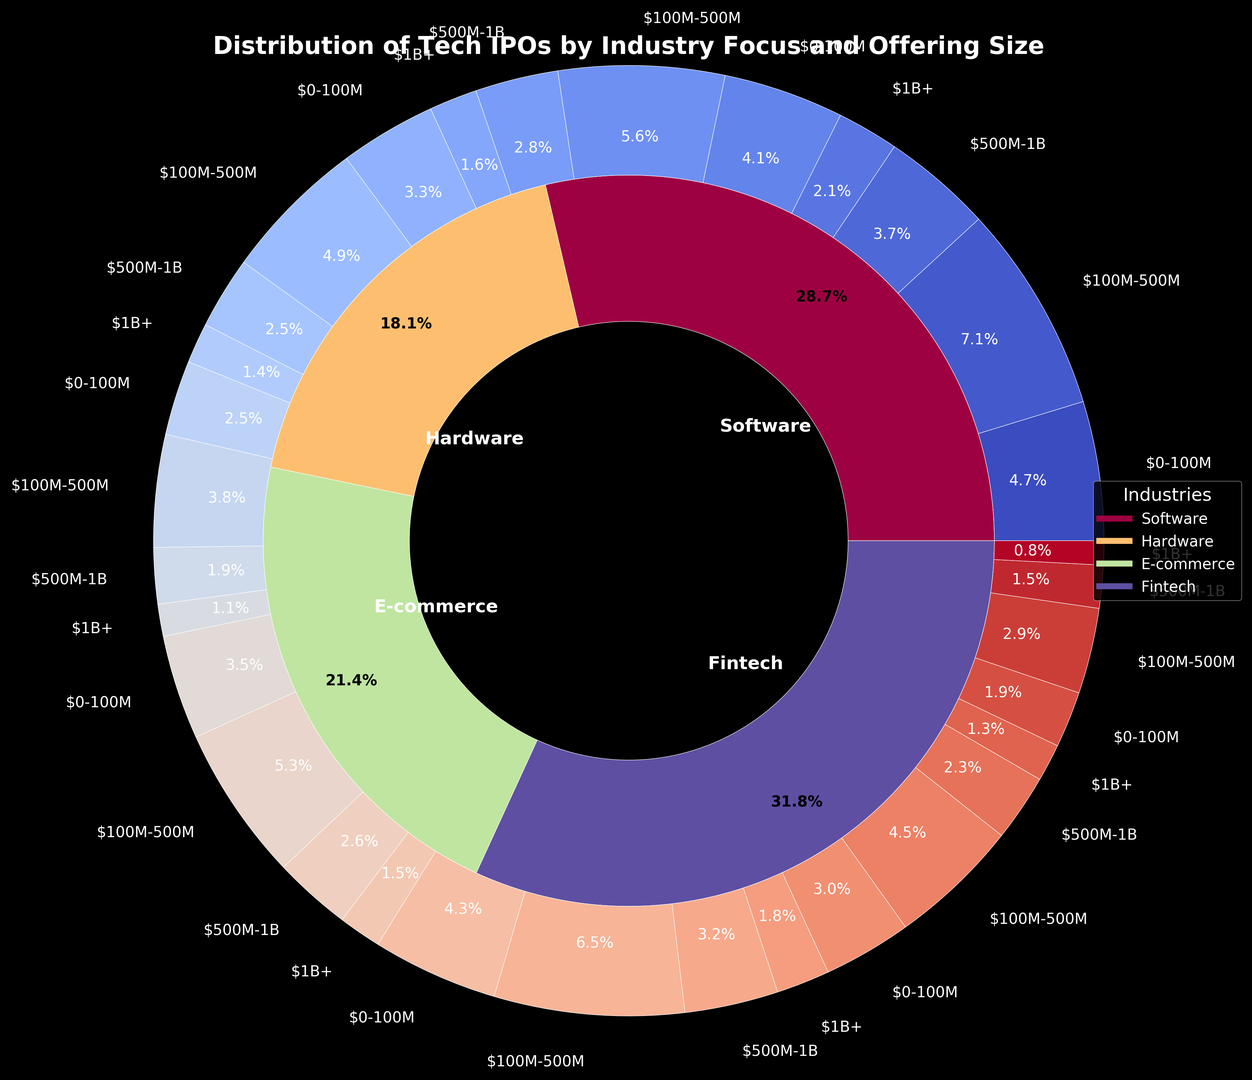What is the total percentage of IPOs in the Software industry? First, locate the "Software" segment in the inner pie chart. Then, sum up the percentages of all sub-segments within it: Enterprise Software and Consumer Software. From the data, Software (Enterprise Software + Consumer Software) = 19.4 (sum of all percentages listed for Software in each offering size range).
Answer: 19.4% Which sub-industry in the Fintech industry has a higher proportion of IPOs, Payment Systems or Blockchain/Crypto? Identify the Fintech portion in the inner chart and then look at the segments for Payment Systems and Blockchain/Crypto in the outer chart. Sum up the percentages for each sub-industry: Payment Systems (3.3 + 4.9 + 2.5 + 1.4 = 12.1%) and Blockchain/Crypto (2.1 + 3.2 + 1.6 + 0.9 = 7.8%). Compare these sums.
Answer: Payment Systems In the Hardware industry, which offering size range has the largest share? Refer to the Hardware segment in the inner pie chart and then check the proportions of the various offering size ranges in the outer pie chart for Hardware. Compare the percentages: $0-100M (3.6 + 2.8 = 6.4%), $100M-500M (5.4 + 4.2 = 9.6%), $500M-$1B (2.7 + 2.1 = 4.8%), and $1B+ (1.5 + 1.2 = 2.7%).
Answer: $100M-$500M Between the industries of E-commerce and Fintech, which has more IPOs with the smallest offering size range ($0-100M)? Locate the E-commerce and Fintech segments in the inner chart. Then, sum the $0-100M percentages for each: E-commerce (B2B: 3.9 + B2C: 4.7 = 8.6%) and Fintech (Payment Systems: 3.3 + Blockchain/Crypto: 2.1 = 5.4%). Compare the summed percentages.
Answer: E-commerce What is the difference in percentages between the $100M-500M offering size range and the $500M-1B offering size range within the Software industry? Identify the percentages for each sub-industry and size range within Software (Enterprise Software $100M-500M: 7.8%, Consumer Software $100M-500M: 6.2% = 14.0%; Enterprise Software $500M-1B: 4.1%, Consumer Software $500M-1B: 3.1% = 7.2%). Calculate the difference between these sums: 14.0% - 7.2%.
Answer: 6.8% Which industry has the smallest percentage of IPOs with the largest offering size range ($1B+)? Examine the data in the outer pie chart for the $1B+ offering size range across all industries and identify the smallest percentage. From the data, compare: Software (Enterprise: 2.3%, Consumer: 1.8%), Hardware (Semiconductors: 1.5%, Computer Hardware: 1.2%), E-commerce (B2B: 1.6%, B2C: 2.0%), Fintech (Payment Systems: 1.4%, Blockchain/Crypto: 0.9%).
Answer: Fintech (Blockchain/Crypto) How much greater is the total percentage of IPOs in E-commerce when compared to the Hardware industry? Sum the total percentages for each sub-industry within these industries from the inner chart and/or data: E-commerce = 3.9 + 5.8 + 2.9 + 1.6 + 4.7 + 7.1 + 3.5 + 2.0 = 31.5%, Hardware = 3.6 + 5.4 + 2.7 + 1.5 + 2.8 + 4.2 + 2.1 + 1.2 = 23.5%. Calculate the difference: 31.5% - 23.5%.
Answer: 8.0% Which sub-industry has the highest percentage of IPOs in the E-commerce industry? Refer to the E-commerce segment in the inner pie chart and compare the sub-industry percentages in the outer pie chart: B2B (3.9% $0-100M, 5.8% $100M-500M, 2.9% $500M-1B, 1.6% $1B+) and B2C (4.7% $0-100M, 7.1% $100M-500M, 3.5% $500M-1B, 2.0% $1B+). The highest individual percentage to note is B2C within the $100M-500M range.
Answer: B2C ($100M-500M) 